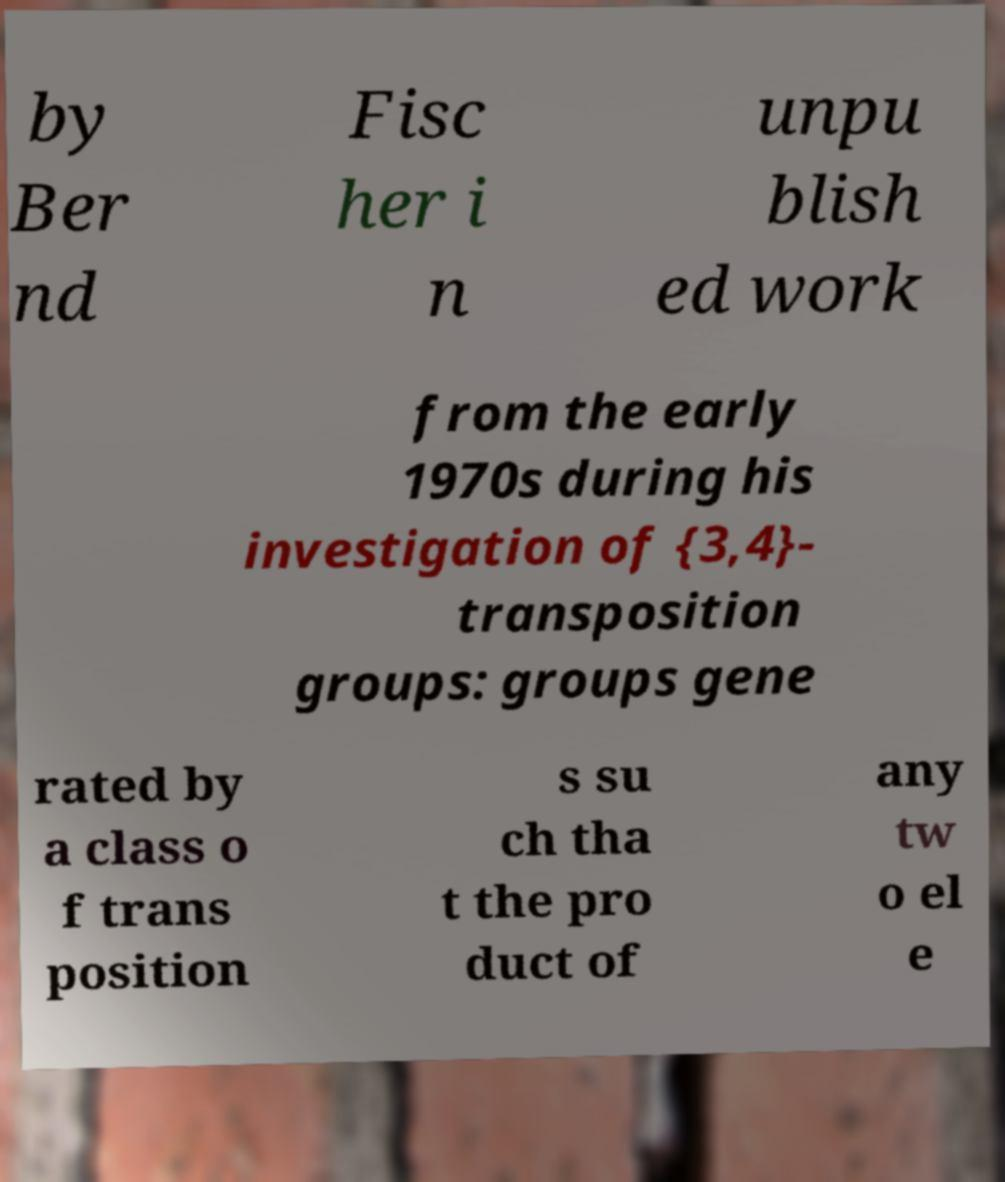Can you accurately transcribe the text from the provided image for me? by Ber nd Fisc her i n unpu blish ed work from the early 1970s during his investigation of {3,4}- transposition groups: groups gene rated by a class o f trans position s su ch tha t the pro duct of any tw o el e 